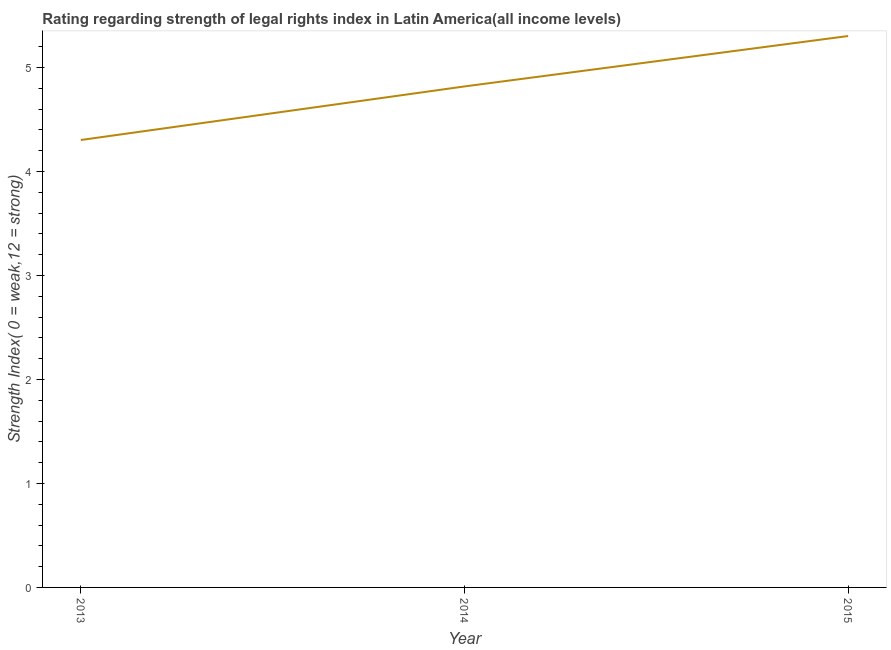What is the strength of legal rights index in 2013?
Make the answer very short. 4.3. Across all years, what is the maximum strength of legal rights index?
Provide a succinct answer. 5.3. Across all years, what is the minimum strength of legal rights index?
Your response must be concise. 4.3. In which year was the strength of legal rights index maximum?
Your response must be concise. 2015. What is the sum of the strength of legal rights index?
Ensure brevity in your answer.  14.42. What is the difference between the strength of legal rights index in 2013 and 2015?
Ensure brevity in your answer.  -1. What is the average strength of legal rights index per year?
Ensure brevity in your answer.  4.81. What is the median strength of legal rights index?
Your response must be concise. 4.82. What is the ratio of the strength of legal rights index in 2013 to that in 2014?
Provide a short and direct response. 0.89. What is the difference between the highest and the second highest strength of legal rights index?
Give a very brief answer. 0.48. Is the sum of the strength of legal rights index in 2014 and 2015 greater than the maximum strength of legal rights index across all years?
Give a very brief answer. Yes. What is the difference between the highest and the lowest strength of legal rights index?
Offer a terse response. 1. Does the strength of legal rights index monotonically increase over the years?
Provide a succinct answer. Yes. How many lines are there?
Your response must be concise. 1. What is the difference between two consecutive major ticks on the Y-axis?
Provide a succinct answer. 1. Are the values on the major ticks of Y-axis written in scientific E-notation?
Provide a succinct answer. No. Does the graph contain grids?
Make the answer very short. No. What is the title of the graph?
Keep it short and to the point. Rating regarding strength of legal rights index in Latin America(all income levels). What is the label or title of the Y-axis?
Your answer should be very brief. Strength Index( 0 = weak,12 = strong). What is the Strength Index( 0 = weak,12 = strong) in 2013?
Ensure brevity in your answer.  4.3. What is the Strength Index( 0 = weak,12 = strong) of 2014?
Your response must be concise. 4.82. What is the Strength Index( 0 = weak,12 = strong) in 2015?
Offer a terse response. 5.3. What is the difference between the Strength Index( 0 = weak,12 = strong) in 2013 and 2014?
Your response must be concise. -0.52. What is the difference between the Strength Index( 0 = weak,12 = strong) in 2014 and 2015?
Provide a short and direct response. -0.48. What is the ratio of the Strength Index( 0 = weak,12 = strong) in 2013 to that in 2014?
Your answer should be very brief. 0.89. What is the ratio of the Strength Index( 0 = weak,12 = strong) in 2013 to that in 2015?
Keep it short and to the point. 0.81. What is the ratio of the Strength Index( 0 = weak,12 = strong) in 2014 to that in 2015?
Your answer should be compact. 0.91. 